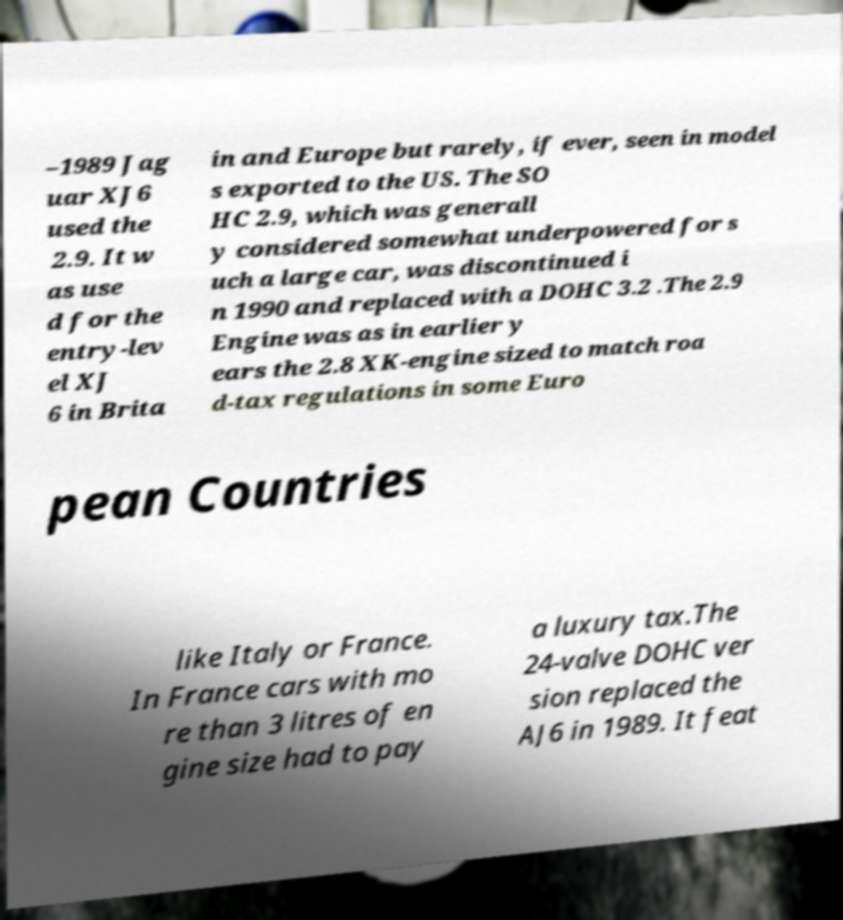Can you accurately transcribe the text from the provided image for me? –1989 Jag uar XJ6 used the 2.9. It w as use d for the entry-lev el XJ 6 in Brita in and Europe but rarely, if ever, seen in model s exported to the US. The SO HC 2.9, which was generall y considered somewhat underpowered for s uch a large car, was discontinued i n 1990 and replaced with a DOHC 3.2 .The 2.9 Engine was as in earlier y ears the 2.8 XK-engine sized to match roa d-tax regulations in some Euro pean Countries like Italy or France. In France cars with mo re than 3 litres of en gine size had to pay a luxury tax.The 24-valve DOHC ver sion replaced the AJ6 in 1989. It feat 